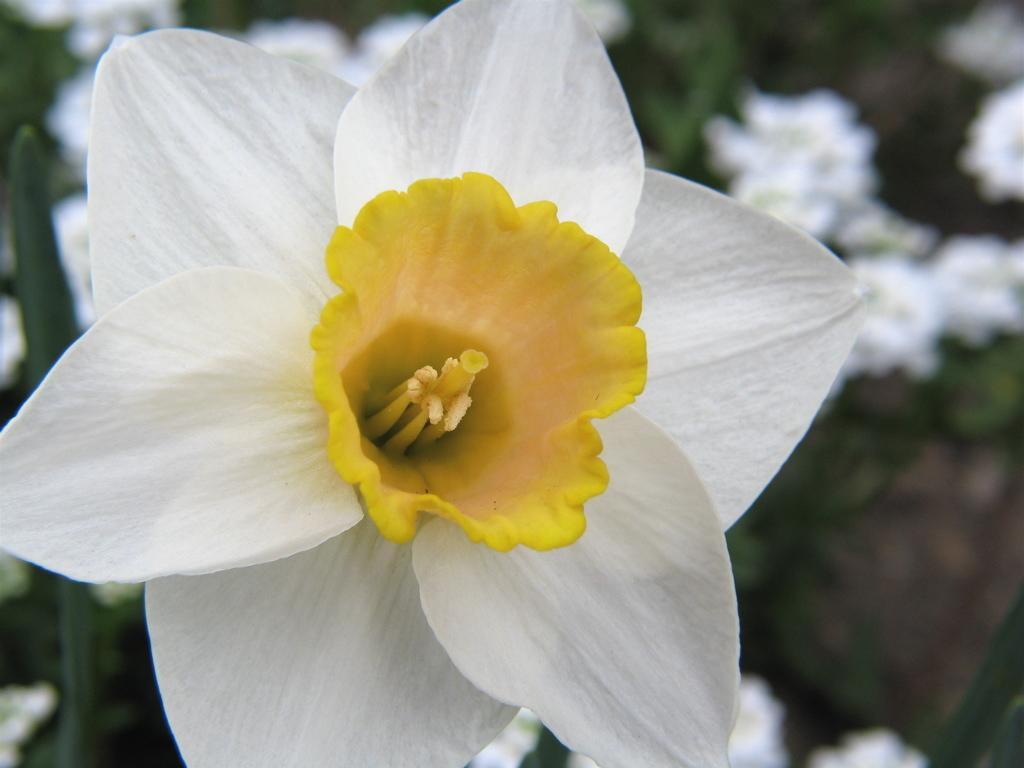What is the color of the main flower in the image? The main flower in the image has white petals. Are there any other flowers visible in the image? Yes, there is a yellow flower in between the petals of the white flower. How is the background of the image presented? The background of the flower is blurred. Can you see any mountains in the background of the image? There are no mountains visible in the background of the image; the background is blurred and only features the flowers. 